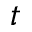Convert formula to latex. <formula><loc_0><loc_0><loc_500><loc_500>t</formula> 